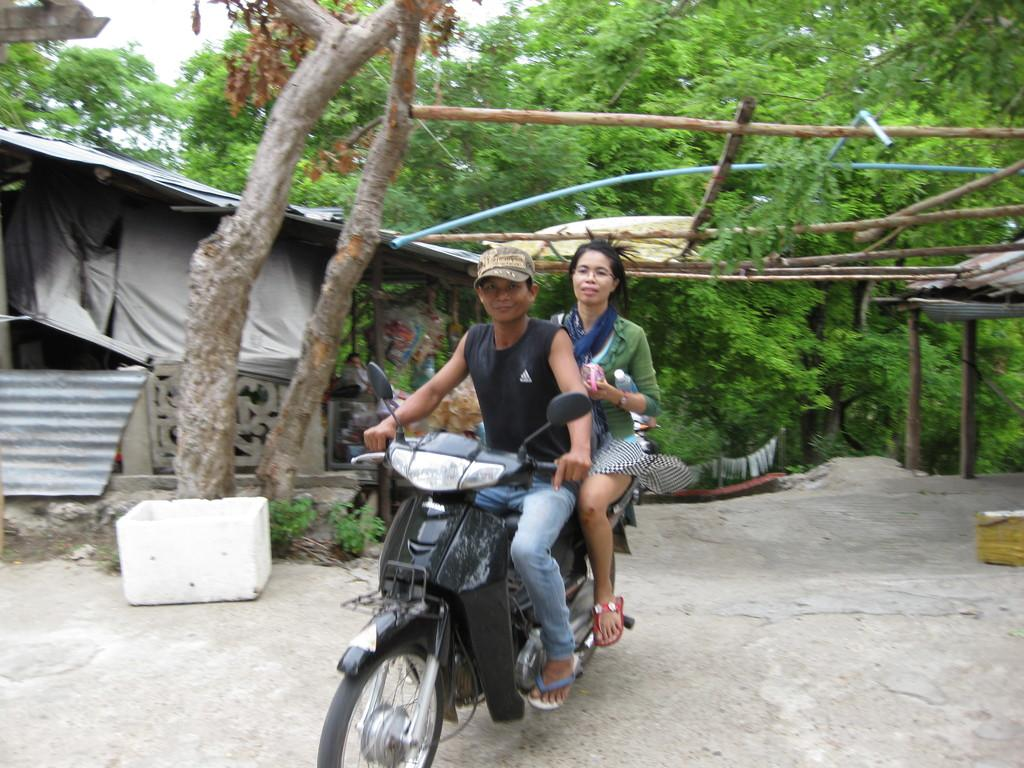What is the man doing in the image? The man is riding a motorbike in the image. Who is with the man on the motorbike? There is a woman sitting behind the man on the motorbike. What type of vegetation can be seen in the image? There are trees in the image. What object is present in the image that could be used for carrying items? There is a basket in the image. What type of structure is visible in the image? There is a shed in the image. What are the poles in the image used for? The purpose of the poles in the image is not specified, but they could be used for various purposes such as supporting wires or marking boundaries. What part of the natural environment is visible in the image? The sky is visible in the image. What type of loaf is being used to reduce pollution in the image? There is no loaf present in the image, and no mention of pollution. What liquid is being used to water the trees in the image? There is no liquid being used to water the trees in the image; the trees are simply visible in the image. 